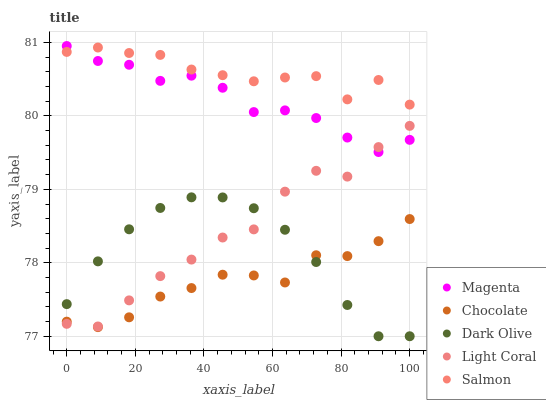Does Chocolate have the minimum area under the curve?
Answer yes or no. Yes. Does Salmon have the maximum area under the curve?
Answer yes or no. Yes. Does Magenta have the minimum area under the curve?
Answer yes or no. No. Does Magenta have the maximum area under the curve?
Answer yes or no. No. Is Dark Olive the smoothest?
Answer yes or no. Yes. Is Light Coral the roughest?
Answer yes or no. Yes. Is Magenta the smoothest?
Answer yes or no. No. Is Magenta the roughest?
Answer yes or no. No. Does Dark Olive have the lowest value?
Answer yes or no. Yes. Does Magenta have the lowest value?
Answer yes or no. No. Does Magenta have the highest value?
Answer yes or no. Yes. Does Dark Olive have the highest value?
Answer yes or no. No. Is Chocolate less than Magenta?
Answer yes or no. Yes. Is Magenta greater than Chocolate?
Answer yes or no. Yes. Does Light Coral intersect Dark Olive?
Answer yes or no. Yes. Is Light Coral less than Dark Olive?
Answer yes or no. No. Is Light Coral greater than Dark Olive?
Answer yes or no. No. Does Chocolate intersect Magenta?
Answer yes or no. No. 